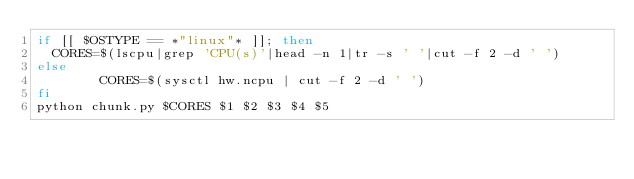Convert code to text. <code><loc_0><loc_0><loc_500><loc_500><_Bash_>if [[ $OSTYPE == *"linux"* ]]; then
	CORES=$(lscpu|grep 'CPU(s)'|head -n 1|tr -s ' '|cut -f 2 -d ' ')
else
        CORES=$(sysctl hw.ncpu | cut -f 2 -d ' ')
fi
python chunk.py $CORES $1 $2 $3 $4 $5
</code> 